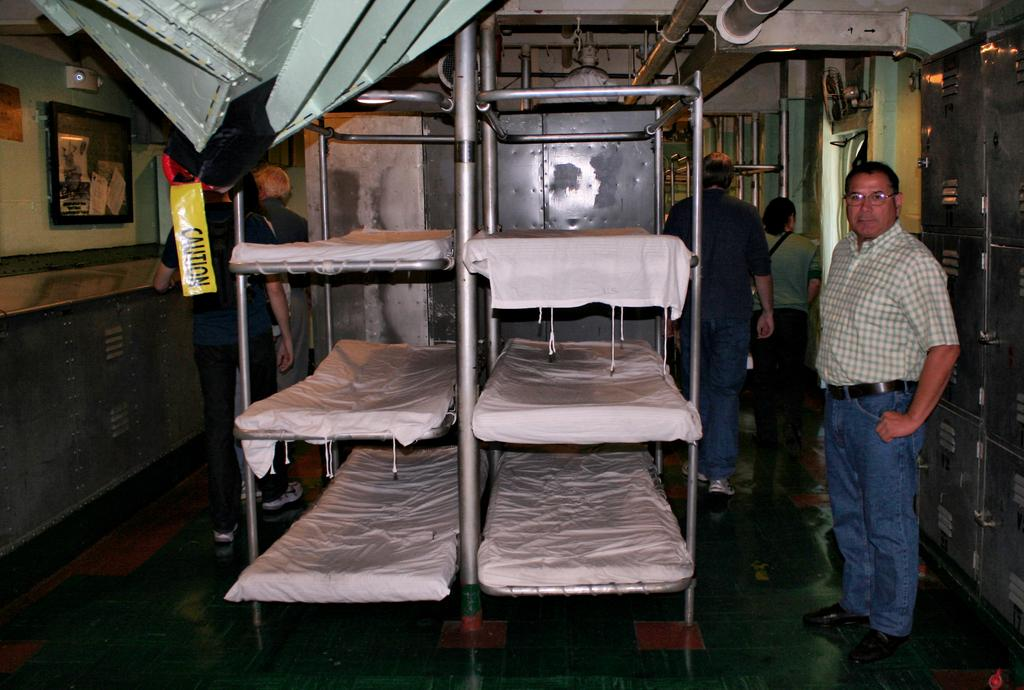<image>
Render a clear and concise summary of the photo. A man is standing by a row of bunk beds where a yellow sign is hanging that says Caution. 